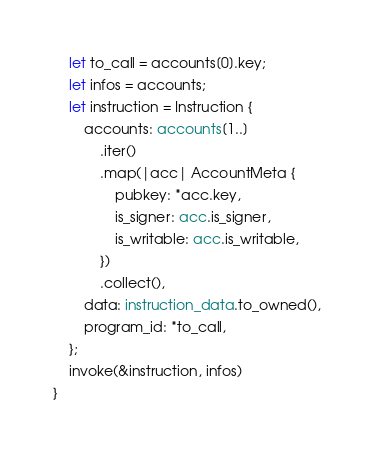Convert code to text. <code><loc_0><loc_0><loc_500><loc_500><_Rust_>    let to_call = accounts[0].key;
    let infos = accounts;
    let instruction = Instruction {
        accounts: accounts[1..]
            .iter()
            .map(|acc| AccountMeta {
                pubkey: *acc.key,
                is_signer: acc.is_signer,
                is_writable: acc.is_writable,
            })
            .collect(),
        data: instruction_data.to_owned(),
        program_id: *to_call,
    };
    invoke(&instruction, infos)
}
</code> 